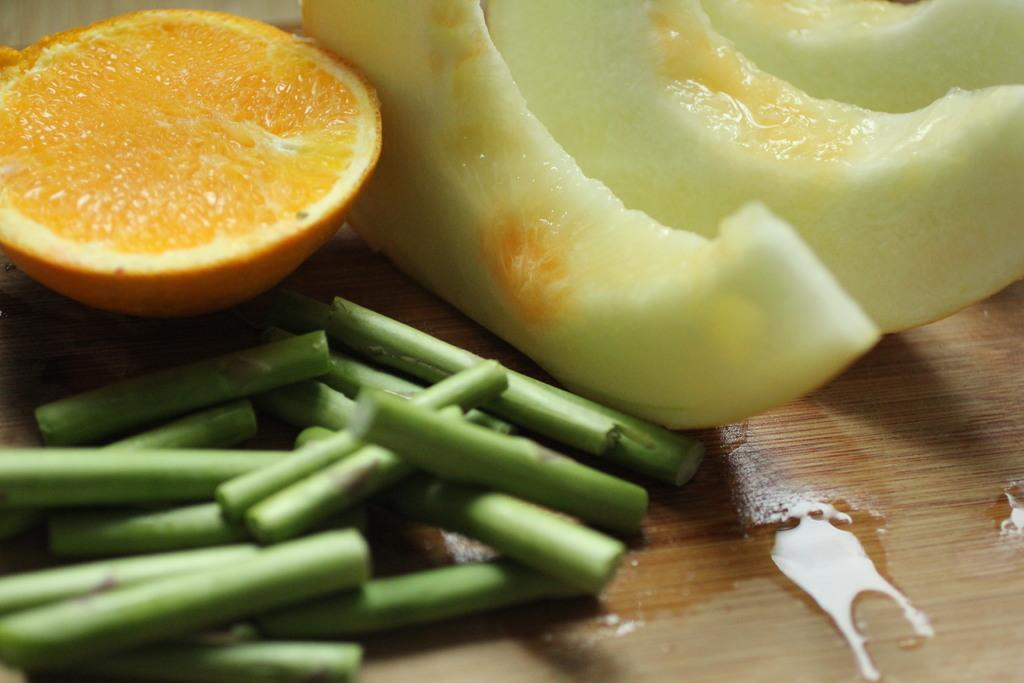What type of food can be seen in the image? There are fruits in the image. How are the fruits presented in the image? The fruits are cut into pieces. Where are the fruits located in the image? The fruits are kept on a table. What type of cake is being served on the table in the image? There is no cake present in the image; it features cut fruits on a table. What type of apparel is being worn by the fruits in the image? Fruits do not wear apparel, as they are inanimate objects. 